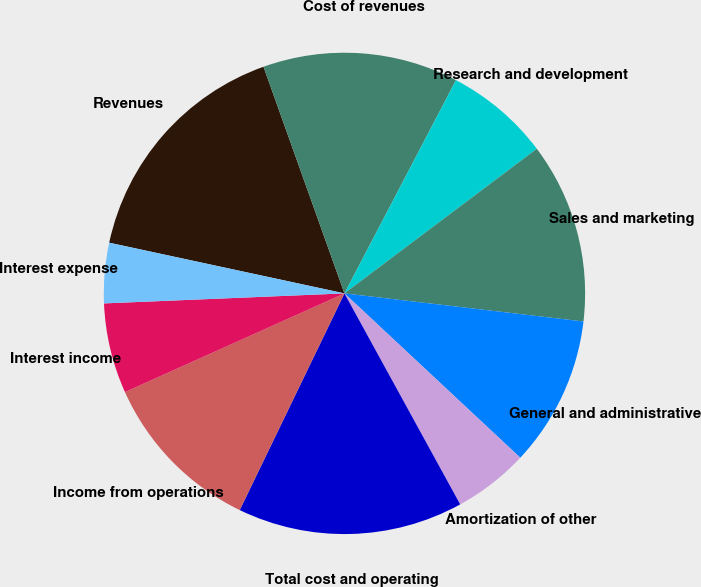Convert chart to OTSL. <chart><loc_0><loc_0><loc_500><loc_500><pie_chart><fcel>Revenues<fcel>Cost of revenues<fcel>Research and development<fcel>Sales and marketing<fcel>General and administrative<fcel>Amortization of other<fcel>Total cost and operating<fcel>Income from operations<fcel>Interest income<fcel>Interest expense<nl><fcel>16.16%<fcel>13.13%<fcel>7.07%<fcel>12.12%<fcel>10.1%<fcel>5.05%<fcel>15.15%<fcel>11.11%<fcel>6.06%<fcel>4.04%<nl></chart> 